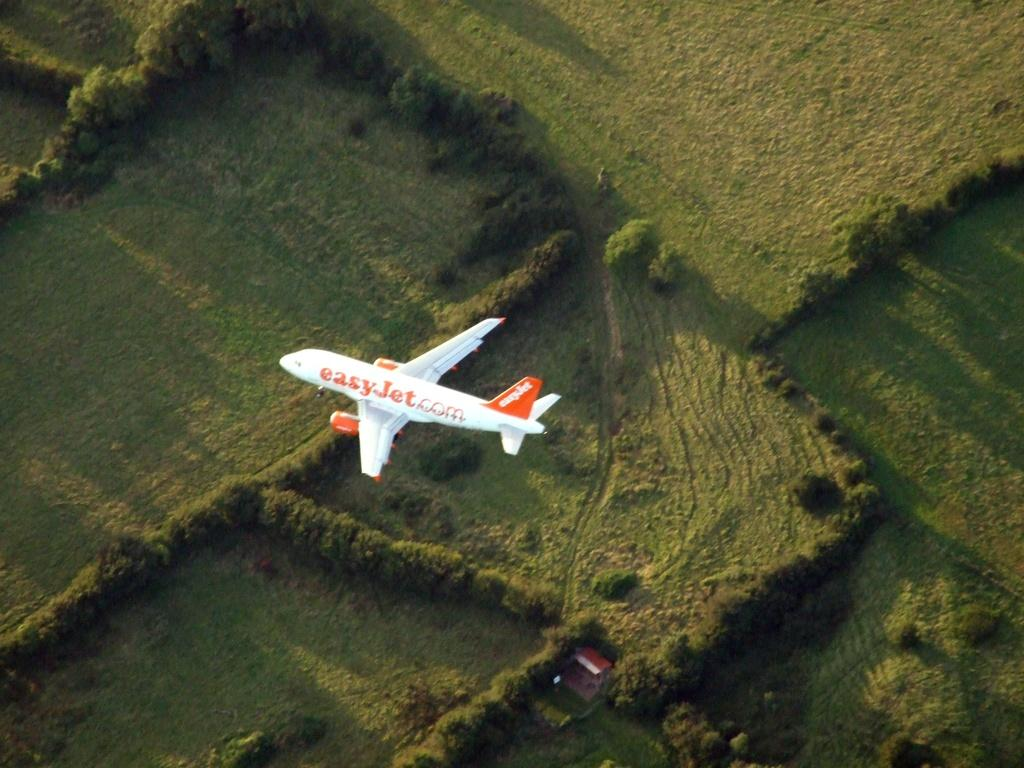<image>
Write a terse but informative summary of the picture. An "Easy Jet" plane flying over a grassy field. 